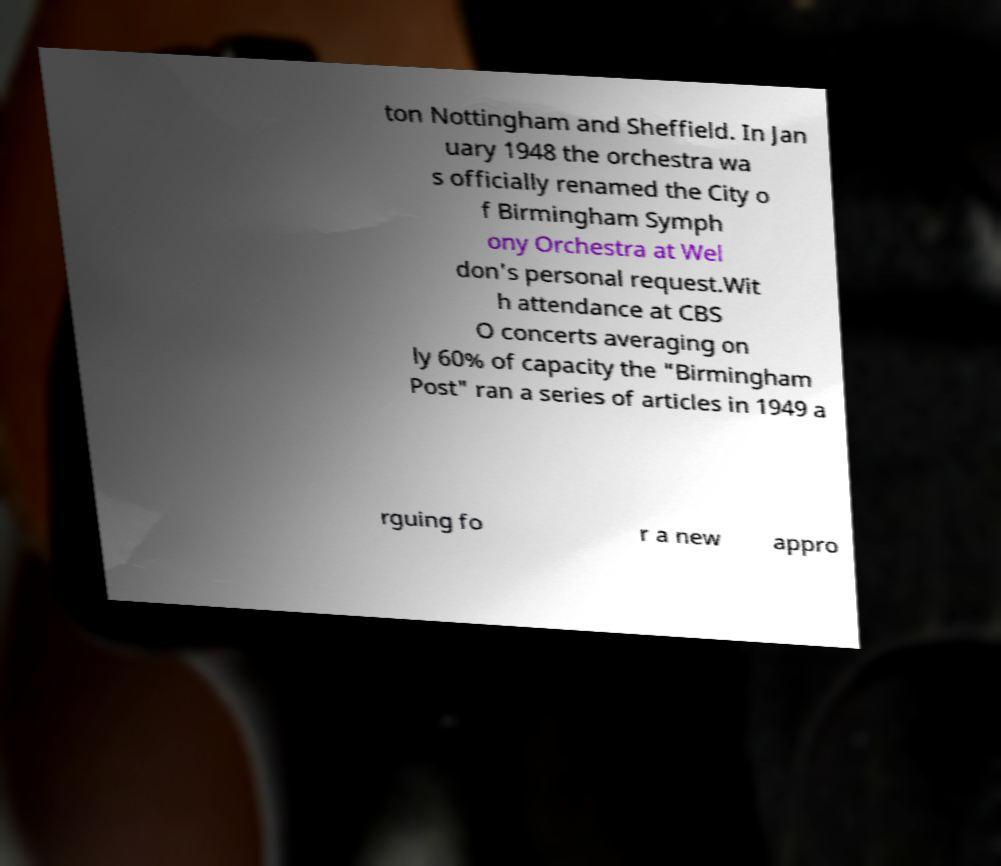What messages or text are displayed in this image? I need them in a readable, typed format. ton Nottingham and Sheffield. In Jan uary 1948 the orchestra wa s officially renamed the City o f Birmingham Symph ony Orchestra at Wel don's personal request.Wit h attendance at CBS O concerts averaging on ly 60% of capacity the "Birmingham Post" ran a series of articles in 1949 a rguing fo r a new appro 